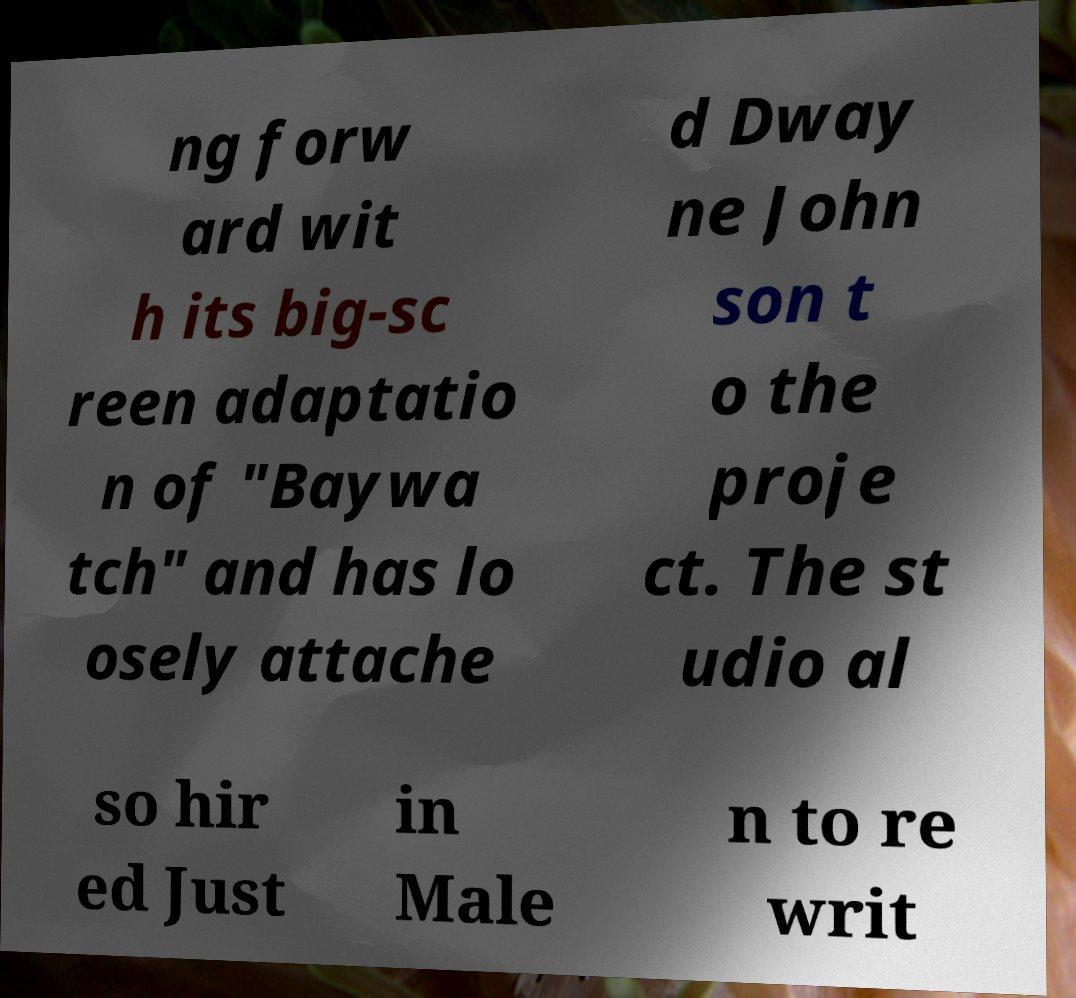Could you extract and type out the text from this image? ng forw ard wit h its big-sc reen adaptatio n of "Baywa tch" and has lo osely attache d Dway ne John son t o the proje ct. The st udio al so hir ed Just in Male n to re writ 